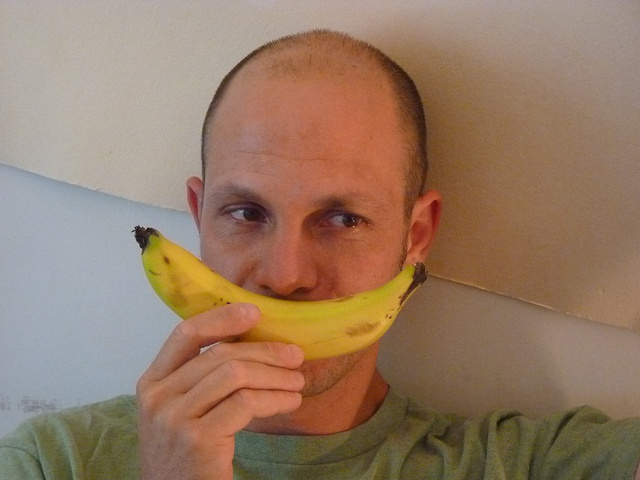Describe the objects in this image and their specific colors. I can see people in darkgray, salmon, olive, brown, and gray tones and banana in darkgray, orange, olive, and brown tones in this image. 